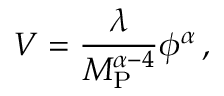Convert formula to latex. <formula><loc_0><loc_0><loc_500><loc_500>V = \frac { \lambda } { M _ { P } ^ { \alpha - 4 } } \phi ^ { \alpha } \, ,</formula> 